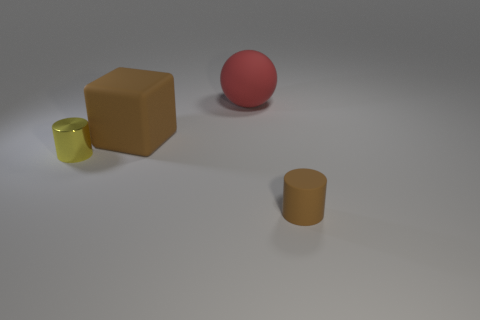Add 1 large brown shiny objects. How many objects exist? 5 Subtract all spheres. How many objects are left? 3 Add 3 tiny metal things. How many tiny metal things are left? 4 Add 2 red matte blocks. How many red matte blocks exist? 2 Subtract 1 yellow cylinders. How many objects are left? 3 Subtract all tiny brown shiny balls. Subtract all brown blocks. How many objects are left? 3 